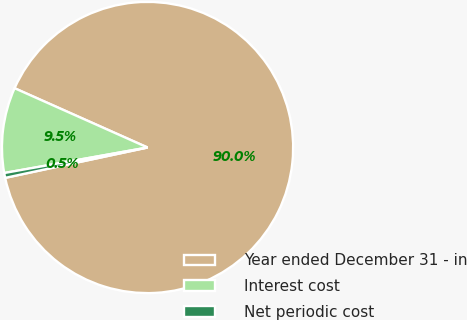<chart> <loc_0><loc_0><loc_500><loc_500><pie_chart><fcel>Year ended December 31 - in<fcel>Interest cost<fcel>Net periodic cost<nl><fcel>89.98%<fcel>9.48%<fcel>0.54%<nl></chart> 